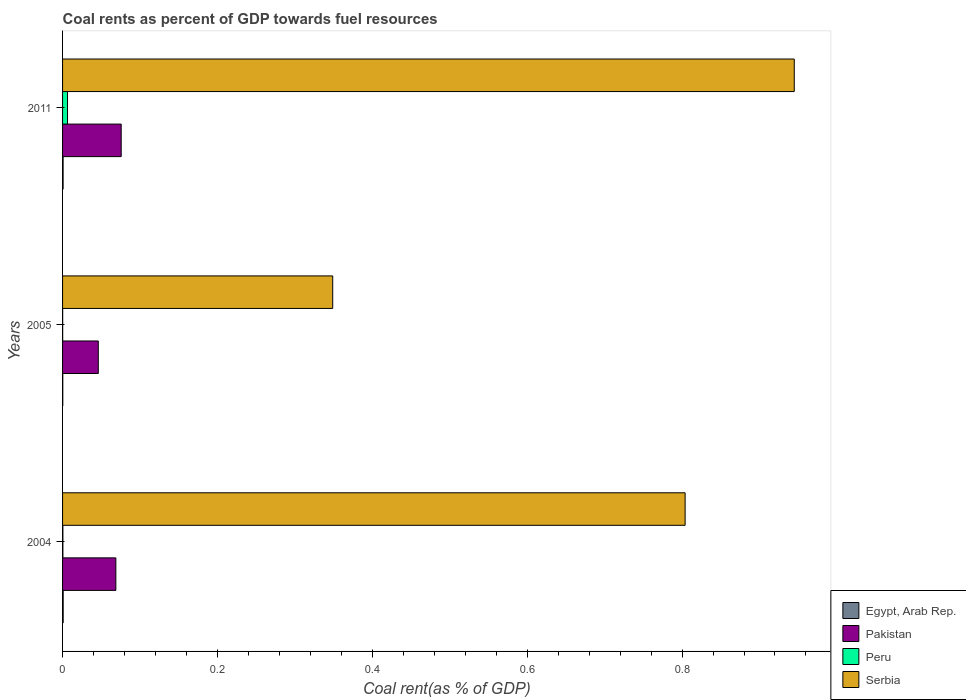How many different coloured bars are there?
Ensure brevity in your answer.  4. Are the number of bars on each tick of the Y-axis equal?
Keep it short and to the point. Yes. How many bars are there on the 1st tick from the top?
Provide a succinct answer. 4. How many bars are there on the 1st tick from the bottom?
Offer a very short reply. 4. What is the coal rent in Pakistan in 2004?
Provide a short and direct response. 0.07. Across all years, what is the maximum coal rent in Serbia?
Your answer should be compact. 0.94. Across all years, what is the minimum coal rent in Serbia?
Keep it short and to the point. 0.35. In which year was the coal rent in Egypt, Arab Rep. maximum?
Provide a succinct answer. 2004. What is the total coal rent in Egypt, Arab Rep. in the graph?
Give a very brief answer. 0. What is the difference between the coal rent in Pakistan in 2004 and that in 2011?
Make the answer very short. -0.01. What is the difference between the coal rent in Serbia in 2004 and the coal rent in Egypt, Arab Rep. in 2005?
Keep it short and to the point. 0.8. What is the average coal rent in Egypt, Arab Rep. per year?
Your answer should be very brief. 0. In the year 2005, what is the difference between the coal rent in Serbia and coal rent in Peru?
Give a very brief answer. 0.35. What is the ratio of the coal rent in Pakistan in 2004 to that in 2011?
Give a very brief answer. 0.91. Is the coal rent in Egypt, Arab Rep. in 2005 less than that in 2011?
Give a very brief answer. Yes. Is the difference between the coal rent in Serbia in 2004 and 2011 greater than the difference between the coal rent in Peru in 2004 and 2011?
Provide a short and direct response. No. What is the difference between the highest and the second highest coal rent in Serbia?
Give a very brief answer. 0.14. What is the difference between the highest and the lowest coal rent in Egypt, Arab Rep.?
Your answer should be compact. 0. In how many years, is the coal rent in Serbia greater than the average coal rent in Serbia taken over all years?
Offer a very short reply. 2. What does the 4th bar from the top in 2004 represents?
Offer a terse response. Egypt, Arab Rep. What does the 4th bar from the bottom in 2004 represents?
Provide a succinct answer. Serbia. Is it the case that in every year, the sum of the coal rent in Serbia and coal rent in Egypt, Arab Rep. is greater than the coal rent in Pakistan?
Offer a terse response. Yes. Are all the bars in the graph horizontal?
Offer a very short reply. Yes. How many years are there in the graph?
Provide a succinct answer. 3. Are the values on the major ticks of X-axis written in scientific E-notation?
Offer a very short reply. No. Does the graph contain any zero values?
Offer a very short reply. No. Where does the legend appear in the graph?
Make the answer very short. Bottom right. How many legend labels are there?
Ensure brevity in your answer.  4. What is the title of the graph?
Make the answer very short. Coal rents as percent of GDP towards fuel resources. What is the label or title of the X-axis?
Offer a terse response. Coal rent(as % of GDP). What is the Coal rent(as % of GDP) of Egypt, Arab Rep. in 2004?
Your answer should be compact. 0. What is the Coal rent(as % of GDP) of Pakistan in 2004?
Provide a succinct answer. 0.07. What is the Coal rent(as % of GDP) of Peru in 2004?
Ensure brevity in your answer.  0. What is the Coal rent(as % of GDP) of Serbia in 2004?
Keep it short and to the point. 0.8. What is the Coal rent(as % of GDP) in Egypt, Arab Rep. in 2005?
Provide a short and direct response. 0. What is the Coal rent(as % of GDP) of Pakistan in 2005?
Ensure brevity in your answer.  0.05. What is the Coal rent(as % of GDP) of Peru in 2005?
Make the answer very short. 0. What is the Coal rent(as % of GDP) in Serbia in 2005?
Provide a succinct answer. 0.35. What is the Coal rent(as % of GDP) in Egypt, Arab Rep. in 2011?
Ensure brevity in your answer.  0. What is the Coal rent(as % of GDP) in Pakistan in 2011?
Give a very brief answer. 0.08. What is the Coal rent(as % of GDP) in Peru in 2011?
Offer a very short reply. 0.01. What is the Coal rent(as % of GDP) of Serbia in 2011?
Ensure brevity in your answer.  0.94. Across all years, what is the maximum Coal rent(as % of GDP) in Egypt, Arab Rep.?
Provide a short and direct response. 0. Across all years, what is the maximum Coal rent(as % of GDP) in Pakistan?
Offer a terse response. 0.08. Across all years, what is the maximum Coal rent(as % of GDP) in Peru?
Ensure brevity in your answer.  0.01. Across all years, what is the maximum Coal rent(as % of GDP) of Serbia?
Provide a short and direct response. 0.94. Across all years, what is the minimum Coal rent(as % of GDP) in Egypt, Arab Rep.?
Your response must be concise. 0. Across all years, what is the minimum Coal rent(as % of GDP) of Pakistan?
Keep it short and to the point. 0.05. Across all years, what is the minimum Coal rent(as % of GDP) of Peru?
Your answer should be very brief. 0. Across all years, what is the minimum Coal rent(as % of GDP) in Serbia?
Provide a succinct answer. 0.35. What is the total Coal rent(as % of GDP) of Egypt, Arab Rep. in the graph?
Your response must be concise. 0. What is the total Coal rent(as % of GDP) of Pakistan in the graph?
Give a very brief answer. 0.19. What is the total Coal rent(as % of GDP) of Peru in the graph?
Make the answer very short. 0.01. What is the total Coal rent(as % of GDP) in Serbia in the graph?
Your answer should be compact. 2.1. What is the difference between the Coal rent(as % of GDP) of Pakistan in 2004 and that in 2005?
Provide a succinct answer. 0.02. What is the difference between the Coal rent(as % of GDP) of Peru in 2004 and that in 2005?
Offer a terse response. 0. What is the difference between the Coal rent(as % of GDP) in Serbia in 2004 and that in 2005?
Keep it short and to the point. 0.46. What is the difference between the Coal rent(as % of GDP) of Egypt, Arab Rep. in 2004 and that in 2011?
Offer a terse response. 0. What is the difference between the Coal rent(as % of GDP) in Pakistan in 2004 and that in 2011?
Provide a short and direct response. -0.01. What is the difference between the Coal rent(as % of GDP) of Peru in 2004 and that in 2011?
Your answer should be very brief. -0.01. What is the difference between the Coal rent(as % of GDP) in Serbia in 2004 and that in 2011?
Your answer should be compact. -0.14. What is the difference between the Coal rent(as % of GDP) in Egypt, Arab Rep. in 2005 and that in 2011?
Your answer should be compact. -0. What is the difference between the Coal rent(as % of GDP) in Pakistan in 2005 and that in 2011?
Ensure brevity in your answer.  -0.03. What is the difference between the Coal rent(as % of GDP) in Peru in 2005 and that in 2011?
Keep it short and to the point. -0.01. What is the difference between the Coal rent(as % of GDP) of Serbia in 2005 and that in 2011?
Provide a succinct answer. -0.6. What is the difference between the Coal rent(as % of GDP) of Egypt, Arab Rep. in 2004 and the Coal rent(as % of GDP) of Pakistan in 2005?
Offer a terse response. -0.05. What is the difference between the Coal rent(as % of GDP) of Egypt, Arab Rep. in 2004 and the Coal rent(as % of GDP) of Peru in 2005?
Offer a very short reply. 0. What is the difference between the Coal rent(as % of GDP) of Egypt, Arab Rep. in 2004 and the Coal rent(as % of GDP) of Serbia in 2005?
Offer a very short reply. -0.35. What is the difference between the Coal rent(as % of GDP) of Pakistan in 2004 and the Coal rent(as % of GDP) of Peru in 2005?
Ensure brevity in your answer.  0.07. What is the difference between the Coal rent(as % of GDP) in Pakistan in 2004 and the Coal rent(as % of GDP) in Serbia in 2005?
Give a very brief answer. -0.28. What is the difference between the Coal rent(as % of GDP) of Peru in 2004 and the Coal rent(as % of GDP) of Serbia in 2005?
Provide a succinct answer. -0.35. What is the difference between the Coal rent(as % of GDP) in Egypt, Arab Rep. in 2004 and the Coal rent(as % of GDP) in Pakistan in 2011?
Provide a short and direct response. -0.07. What is the difference between the Coal rent(as % of GDP) of Egypt, Arab Rep. in 2004 and the Coal rent(as % of GDP) of Peru in 2011?
Your answer should be compact. -0.01. What is the difference between the Coal rent(as % of GDP) in Egypt, Arab Rep. in 2004 and the Coal rent(as % of GDP) in Serbia in 2011?
Make the answer very short. -0.94. What is the difference between the Coal rent(as % of GDP) of Pakistan in 2004 and the Coal rent(as % of GDP) of Peru in 2011?
Ensure brevity in your answer.  0.06. What is the difference between the Coal rent(as % of GDP) of Pakistan in 2004 and the Coal rent(as % of GDP) of Serbia in 2011?
Give a very brief answer. -0.88. What is the difference between the Coal rent(as % of GDP) in Peru in 2004 and the Coal rent(as % of GDP) in Serbia in 2011?
Provide a succinct answer. -0.94. What is the difference between the Coal rent(as % of GDP) of Egypt, Arab Rep. in 2005 and the Coal rent(as % of GDP) of Pakistan in 2011?
Offer a terse response. -0.08. What is the difference between the Coal rent(as % of GDP) in Egypt, Arab Rep. in 2005 and the Coal rent(as % of GDP) in Peru in 2011?
Offer a very short reply. -0.01. What is the difference between the Coal rent(as % of GDP) of Egypt, Arab Rep. in 2005 and the Coal rent(as % of GDP) of Serbia in 2011?
Your answer should be very brief. -0.94. What is the difference between the Coal rent(as % of GDP) of Pakistan in 2005 and the Coal rent(as % of GDP) of Peru in 2011?
Make the answer very short. 0.04. What is the difference between the Coal rent(as % of GDP) of Pakistan in 2005 and the Coal rent(as % of GDP) of Serbia in 2011?
Offer a terse response. -0.9. What is the difference between the Coal rent(as % of GDP) of Peru in 2005 and the Coal rent(as % of GDP) of Serbia in 2011?
Give a very brief answer. -0.94. What is the average Coal rent(as % of GDP) in Egypt, Arab Rep. per year?
Offer a very short reply. 0. What is the average Coal rent(as % of GDP) of Pakistan per year?
Provide a succinct answer. 0.06. What is the average Coal rent(as % of GDP) of Peru per year?
Your answer should be very brief. 0. What is the average Coal rent(as % of GDP) of Serbia per year?
Your response must be concise. 0.7. In the year 2004, what is the difference between the Coal rent(as % of GDP) of Egypt, Arab Rep. and Coal rent(as % of GDP) of Pakistan?
Provide a short and direct response. -0.07. In the year 2004, what is the difference between the Coal rent(as % of GDP) of Egypt, Arab Rep. and Coal rent(as % of GDP) of Peru?
Your response must be concise. 0. In the year 2004, what is the difference between the Coal rent(as % of GDP) of Egypt, Arab Rep. and Coal rent(as % of GDP) of Serbia?
Your answer should be compact. -0.8. In the year 2004, what is the difference between the Coal rent(as % of GDP) in Pakistan and Coal rent(as % of GDP) in Peru?
Offer a terse response. 0.07. In the year 2004, what is the difference between the Coal rent(as % of GDP) of Pakistan and Coal rent(as % of GDP) of Serbia?
Make the answer very short. -0.74. In the year 2004, what is the difference between the Coal rent(as % of GDP) of Peru and Coal rent(as % of GDP) of Serbia?
Your answer should be very brief. -0.8. In the year 2005, what is the difference between the Coal rent(as % of GDP) of Egypt, Arab Rep. and Coal rent(as % of GDP) of Pakistan?
Your answer should be compact. -0.05. In the year 2005, what is the difference between the Coal rent(as % of GDP) of Egypt, Arab Rep. and Coal rent(as % of GDP) of Peru?
Your answer should be compact. 0. In the year 2005, what is the difference between the Coal rent(as % of GDP) of Egypt, Arab Rep. and Coal rent(as % of GDP) of Serbia?
Provide a succinct answer. -0.35. In the year 2005, what is the difference between the Coal rent(as % of GDP) in Pakistan and Coal rent(as % of GDP) in Peru?
Keep it short and to the point. 0.05. In the year 2005, what is the difference between the Coal rent(as % of GDP) of Pakistan and Coal rent(as % of GDP) of Serbia?
Your answer should be compact. -0.3. In the year 2005, what is the difference between the Coal rent(as % of GDP) in Peru and Coal rent(as % of GDP) in Serbia?
Make the answer very short. -0.35. In the year 2011, what is the difference between the Coal rent(as % of GDP) in Egypt, Arab Rep. and Coal rent(as % of GDP) in Pakistan?
Give a very brief answer. -0.07. In the year 2011, what is the difference between the Coal rent(as % of GDP) of Egypt, Arab Rep. and Coal rent(as % of GDP) of Peru?
Offer a very short reply. -0.01. In the year 2011, what is the difference between the Coal rent(as % of GDP) in Egypt, Arab Rep. and Coal rent(as % of GDP) in Serbia?
Ensure brevity in your answer.  -0.94. In the year 2011, what is the difference between the Coal rent(as % of GDP) in Pakistan and Coal rent(as % of GDP) in Peru?
Offer a terse response. 0.07. In the year 2011, what is the difference between the Coal rent(as % of GDP) of Pakistan and Coal rent(as % of GDP) of Serbia?
Give a very brief answer. -0.87. In the year 2011, what is the difference between the Coal rent(as % of GDP) in Peru and Coal rent(as % of GDP) in Serbia?
Your answer should be very brief. -0.94. What is the ratio of the Coal rent(as % of GDP) in Egypt, Arab Rep. in 2004 to that in 2005?
Your response must be concise. 2.83. What is the ratio of the Coal rent(as % of GDP) of Pakistan in 2004 to that in 2005?
Ensure brevity in your answer.  1.49. What is the ratio of the Coal rent(as % of GDP) in Peru in 2004 to that in 2005?
Offer a very short reply. 3.1. What is the ratio of the Coal rent(as % of GDP) of Serbia in 2004 to that in 2005?
Ensure brevity in your answer.  2.3. What is the ratio of the Coal rent(as % of GDP) in Egypt, Arab Rep. in 2004 to that in 2011?
Offer a very short reply. 1.13. What is the ratio of the Coal rent(as % of GDP) in Pakistan in 2004 to that in 2011?
Ensure brevity in your answer.  0.91. What is the ratio of the Coal rent(as % of GDP) in Peru in 2004 to that in 2011?
Give a very brief answer. 0.07. What is the ratio of the Coal rent(as % of GDP) in Serbia in 2004 to that in 2011?
Your answer should be very brief. 0.85. What is the ratio of the Coal rent(as % of GDP) in Egypt, Arab Rep. in 2005 to that in 2011?
Your answer should be very brief. 0.4. What is the ratio of the Coal rent(as % of GDP) in Pakistan in 2005 to that in 2011?
Your answer should be very brief. 0.61. What is the ratio of the Coal rent(as % of GDP) in Peru in 2005 to that in 2011?
Your answer should be compact. 0.02. What is the ratio of the Coal rent(as % of GDP) of Serbia in 2005 to that in 2011?
Your response must be concise. 0.37. What is the difference between the highest and the second highest Coal rent(as % of GDP) in Pakistan?
Offer a terse response. 0.01. What is the difference between the highest and the second highest Coal rent(as % of GDP) in Peru?
Your answer should be very brief. 0.01. What is the difference between the highest and the second highest Coal rent(as % of GDP) of Serbia?
Offer a very short reply. 0.14. What is the difference between the highest and the lowest Coal rent(as % of GDP) of Pakistan?
Keep it short and to the point. 0.03. What is the difference between the highest and the lowest Coal rent(as % of GDP) in Peru?
Offer a terse response. 0.01. What is the difference between the highest and the lowest Coal rent(as % of GDP) in Serbia?
Give a very brief answer. 0.6. 